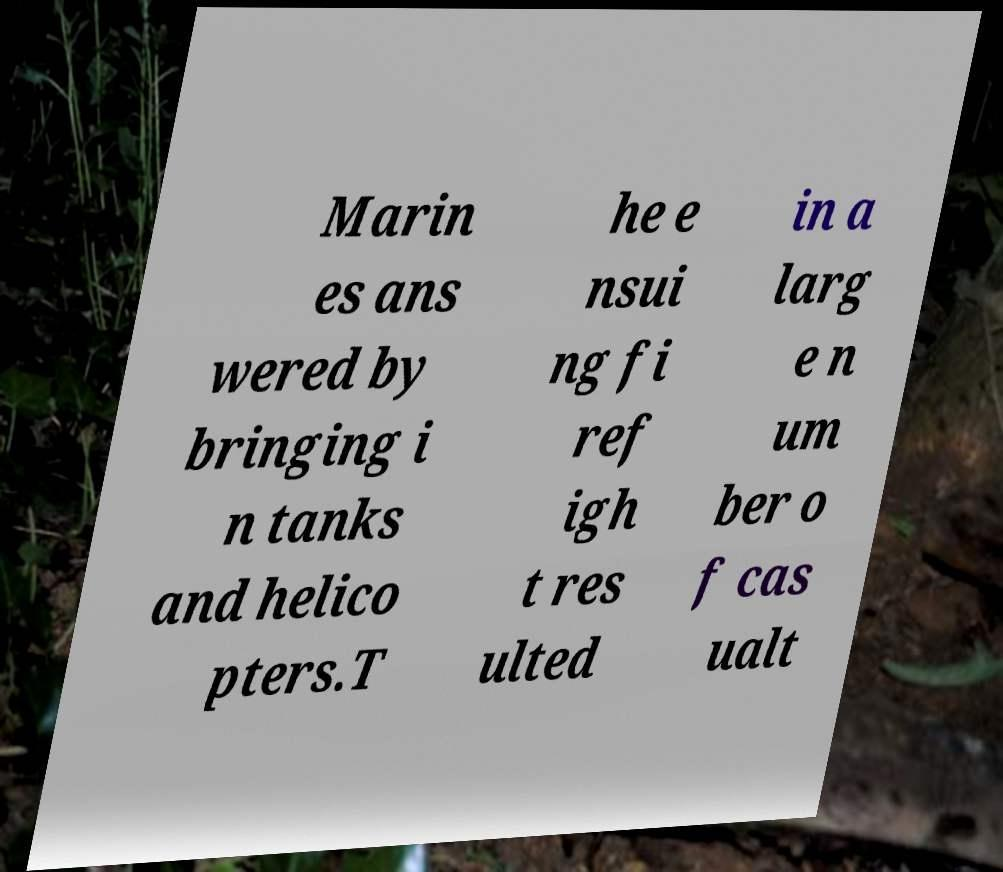For documentation purposes, I need the text within this image transcribed. Could you provide that? Marin es ans wered by bringing i n tanks and helico pters.T he e nsui ng fi ref igh t res ulted in a larg e n um ber o f cas ualt 